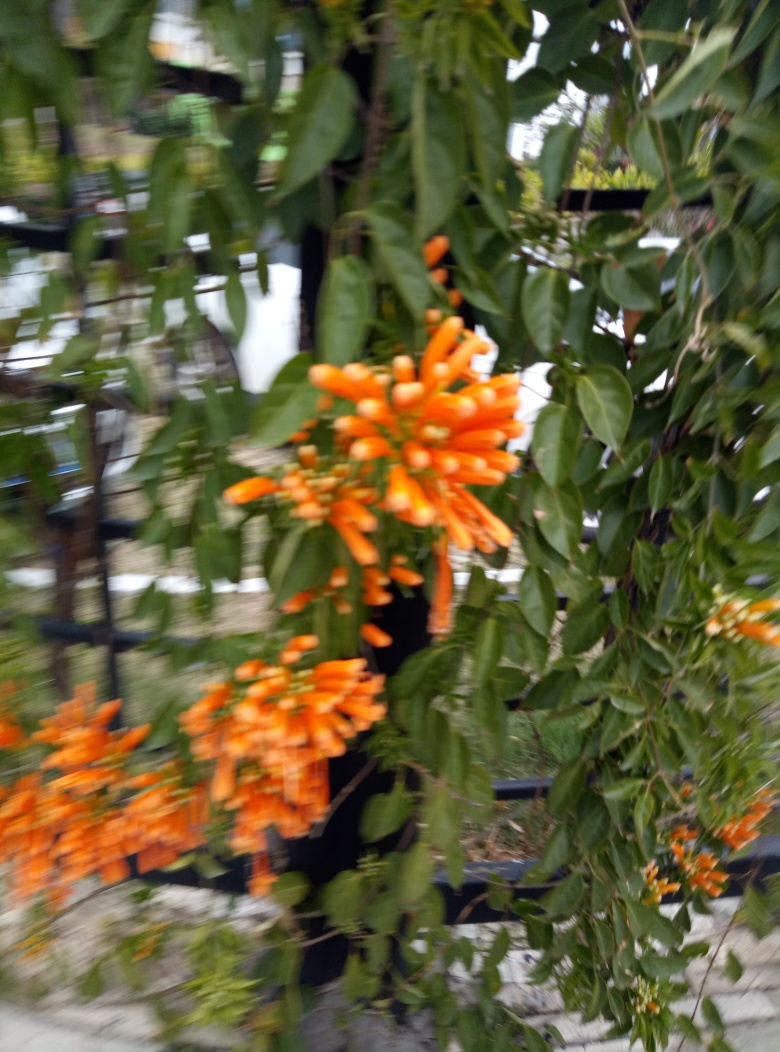What are the details of the flower like? The orange flowers in the image have tubular shapes with multiple long stamens extending outward. They are arranged in clusters and appear to be a type of trumpet vine, known for their vibrant color and attractiveness to hummingbirds. 